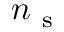<formula> <loc_0><loc_0><loc_500><loc_500>n _ { s }</formula> 